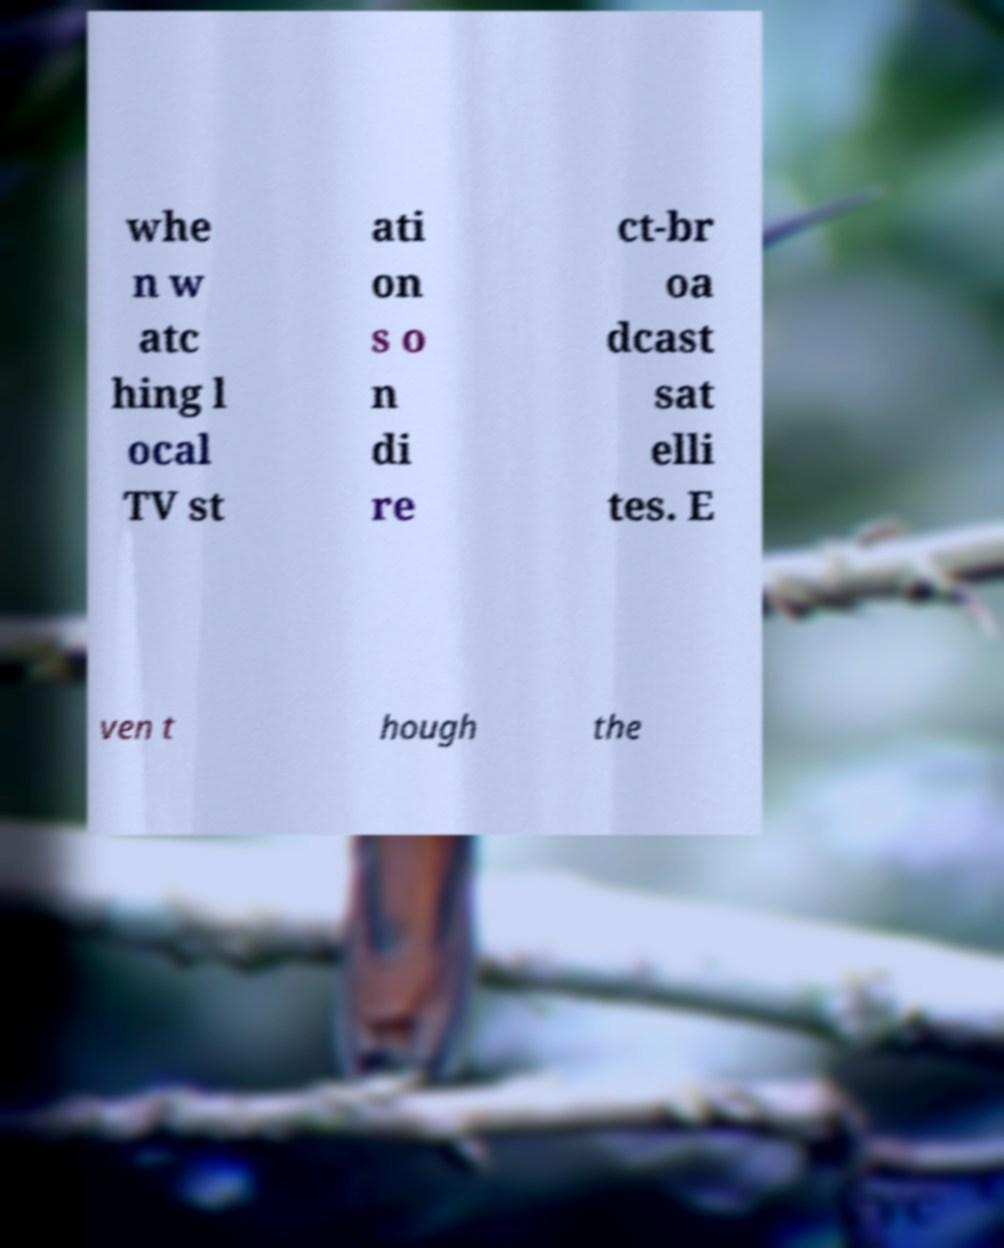Please read and relay the text visible in this image. What does it say? whe n w atc hing l ocal TV st ati on s o n di re ct-br oa dcast sat elli tes. E ven t hough the 